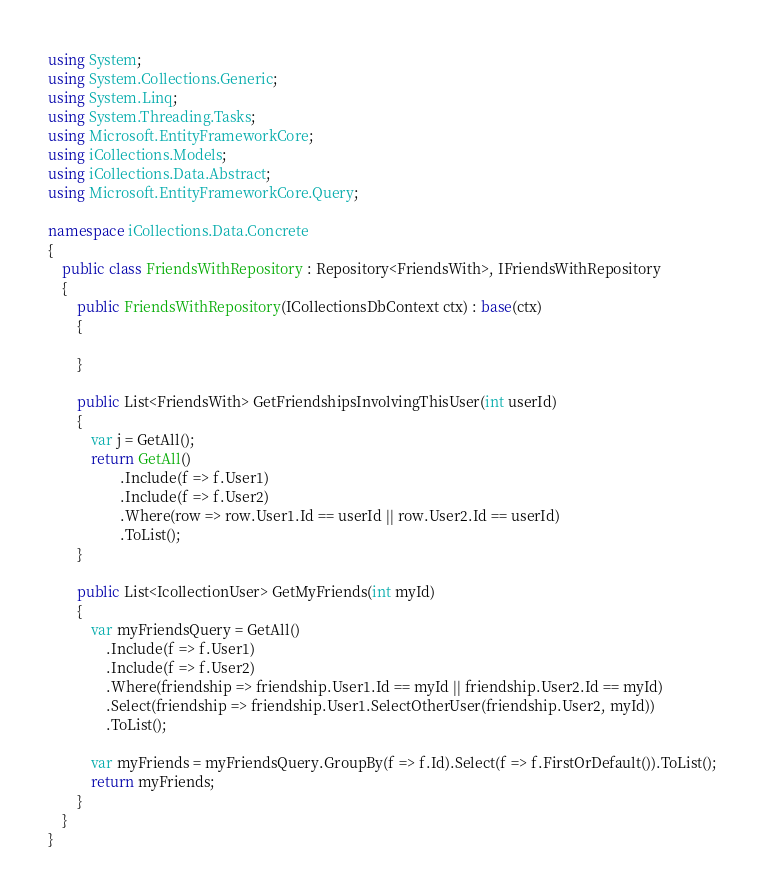Convert code to text. <code><loc_0><loc_0><loc_500><loc_500><_C#_>using System;
using System.Collections.Generic;
using System.Linq;
using System.Threading.Tasks;
using Microsoft.EntityFrameworkCore;
using iCollections.Models;
using iCollections.Data.Abstract;
using Microsoft.EntityFrameworkCore.Query;

namespace iCollections.Data.Concrete
{
    public class FriendsWithRepository : Repository<FriendsWith>, IFriendsWithRepository
    {
        public FriendsWithRepository(ICollectionsDbContext ctx) : base(ctx)
        {

        }

        public List<FriendsWith> GetFriendshipsInvolvingThisUser(int userId)
        {
            var j = GetAll();
            return GetAll()
                    .Include(f => f.User1)
                    .Include(f => f.User2)
                    .Where(row => row.User1.Id == userId || row.User2.Id == userId)
                    .ToList();
        }

        public List<IcollectionUser> GetMyFriends(int myId)
        {
            var myFriendsQuery = GetAll()
                .Include(f => f.User1)
                .Include(f => f.User2)
                .Where(friendship => friendship.User1.Id == myId || friendship.User2.Id == myId)
                .Select(friendship => friendship.User1.SelectOtherUser(friendship.User2, myId))
                .ToList();

            var myFriends = myFriendsQuery.GroupBy(f => f.Id).Select(f => f.FirstOrDefault()).ToList();
            return myFriends;
        }
    }
}
</code> 